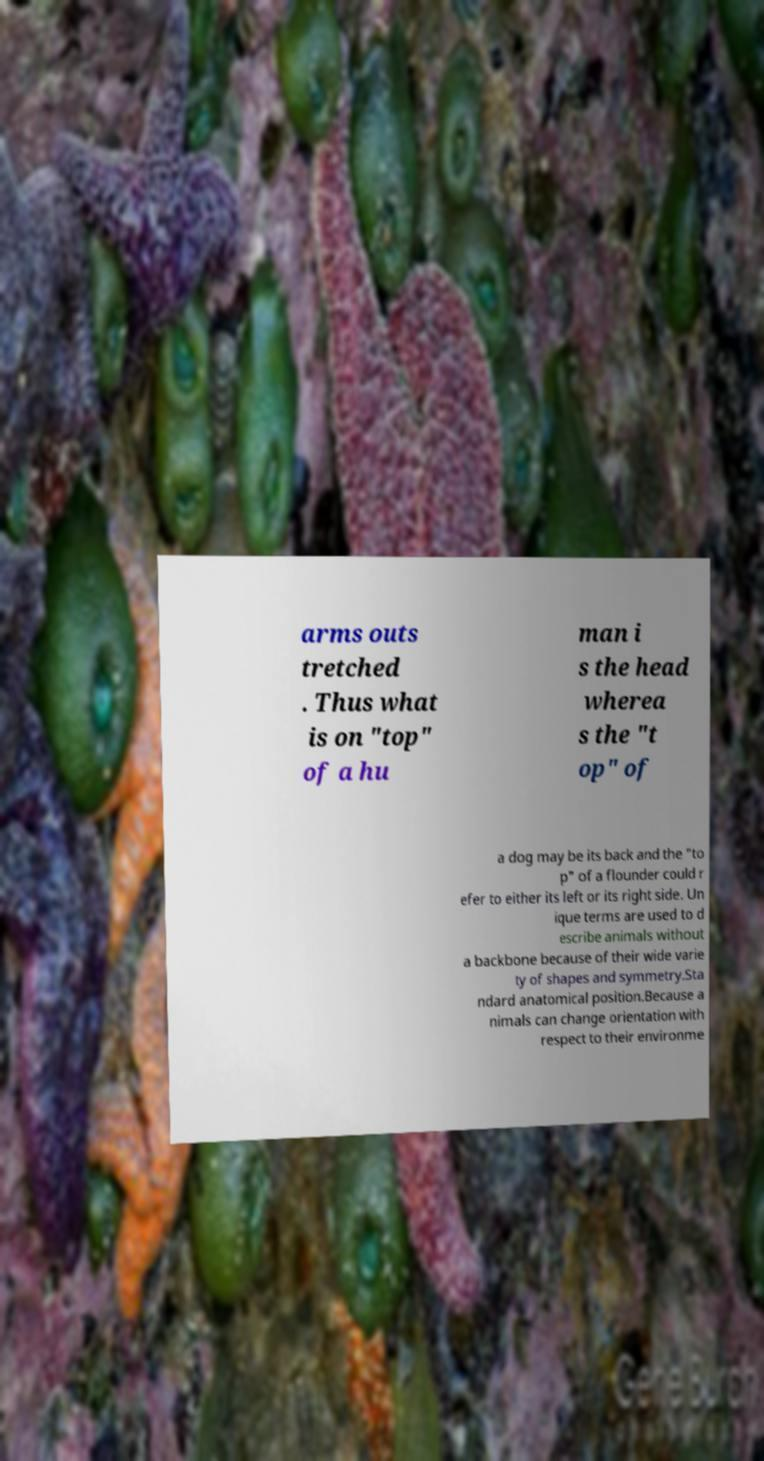Please identify and transcribe the text found in this image. arms outs tretched . Thus what is on "top" of a hu man i s the head wherea s the "t op" of a dog may be its back and the "to p" of a flounder could r efer to either its left or its right side. Un ique terms are used to d escribe animals without a backbone because of their wide varie ty of shapes and symmetry.Sta ndard anatomical position.Because a nimals can change orientation with respect to their environme 